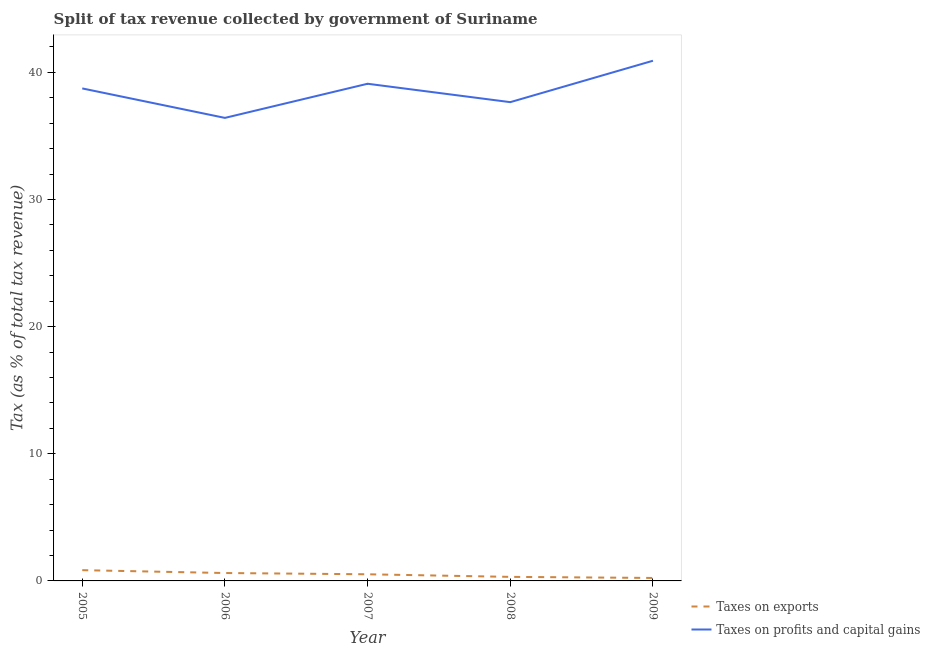How many different coloured lines are there?
Offer a very short reply. 2. Is the number of lines equal to the number of legend labels?
Your answer should be very brief. Yes. What is the percentage of revenue obtained from taxes on exports in 2005?
Your response must be concise. 0.85. Across all years, what is the maximum percentage of revenue obtained from taxes on profits and capital gains?
Provide a short and direct response. 40.91. Across all years, what is the minimum percentage of revenue obtained from taxes on exports?
Your answer should be very brief. 0.23. In which year was the percentage of revenue obtained from taxes on exports maximum?
Offer a terse response. 2005. What is the total percentage of revenue obtained from taxes on profits and capital gains in the graph?
Provide a short and direct response. 192.81. What is the difference between the percentage of revenue obtained from taxes on profits and capital gains in 2007 and that in 2009?
Make the answer very short. -1.81. What is the difference between the percentage of revenue obtained from taxes on exports in 2007 and the percentage of revenue obtained from taxes on profits and capital gains in 2005?
Offer a very short reply. -38.21. What is the average percentage of revenue obtained from taxes on profits and capital gains per year?
Ensure brevity in your answer.  38.56. In the year 2008, what is the difference between the percentage of revenue obtained from taxes on profits and capital gains and percentage of revenue obtained from taxes on exports?
Your answer should be very brief. 37.33. What is the ratio of the percentage of revenue obtained from taxes on exports in 2005 to that in 2007?
Provide a short and direct response. 1.62. What is the difference between the highest and the second highest percentage of revenue obtained from taxes on profits and capital gains?
Give a very brief answer. 1.81. What is the difference between the highest and the lowest percentage of revenue obtained from taxes on exports?
Make the answer very short. 0.61. In how many years, is the percentage of revenue obtained from taxes on profits and capital gains greater than the average percentage of revenue obtained from taxes on profits and capital gains taken over all years?
Give a very brief answer. 3. Is the sum of the percentage of revenue obtained from taxes on profits and capital gains in 2006 and 2008 greater than the maximum percentage of revenue obtained from taxes on exports across all years?
Ensure brevity in your answer.  Yes. Does the percentage of revenue obtained from taxes on exports monotonically increase over the years?
Ensure brevity in your answer.  No. Is the percentage of revenue obtained from taxes on profits and capital gains strictly less than the percentage of revenue obtained from taxes on exports over the years?
Ensure brevity in your answer.  No. How many years are there in the graph?
Keep it short and to the point. 5. Are the values on the major ticks of Y-axis written in scientific E-notation?
Your response must be concise. No. Does the graph contain grids?
Provide a succinct answer. No. How many legend labels are there?
Offer a terse response. 2. How are the legend labels stacked?
Your answer should be compact. Vertical. What is the title of the graph?
Your response must be concise. Split of tax revenue collected by government of Suriname. What is the label or title of the X-axis?
Your answer should be compact. Year. What is the label or title of the Y-axis?
Your answer should be compact. Tax (as % of total tax revenue). What is the Tax (as % of total tax revenue) of Taxes on exports in 2005?
Your answer should be very brief. 0.85. What is the Tax (as % of total tax revenue) in Taxes on profits and capital gains in 2005?
Provide a succinct answer. 38.73. What is the Tax (as % of total tax revenue) in Taxes on exports in 2006?
Make the answer very short. 0.62. What is the Tax (as % of total tax revenue) of Taxes on profits and capital gains in 2006?
Your answer should be compact. 36.42. What is the Tax (as % of total tax revenue) of Taxes on exports in 2007?
Your answer should be compact. 0.52. What is the Tax (as % of total tax revenue) in Taxes on profits and capital gains in 2007?
Offer a very short reply. 39.1. What is the Tax (as % of total tax revenue) of Taxes on exports in 2008?
Give a very brief answer. 0.32. What is the Tax (as % of total tax revenue) of Taxes on profits and capital gains in 2008?
Your answer should be very brief. 37.65. What is the Tax (as % of total tax revenue) in Taxes on exports in 2009?
Keep it short and to the point. 0.23. What is the Tax (as % of total tax revenue) of Taxes on profits and capital gains in 2009?
Your response must be concise. 40.91. Across all years, what is the maximum Tax (as % of total tax revenue) in Taxes on exports?
Provide a succinct answer. 0.85. Across all years, what is the maximum Tax (as % of total tax revenue) of Taxes on profits and capital gains?
Ensure brevity in your answer.  40.91. Across all years, what is the minimum Tax (as % of total tax revenue) in Taxes on exports?
Your answer should be compact. 0.23. Across all years, what is the minimum Tax (as % of total tax revenue) in Taxes on profits and capital gains?
Ensure brevity in your answer.  36.42. What is the total Tax (as % of total tax revenue) of Taxes on exports in the graph?
Offer a very short reply. 2.54. What is the total Tax (as % of total tax revenue) of Taxes on profits and capital gains in the graph?
Keep it short and to the point. 192.81. What is the difference between the Tax (as % of total tax revenue) in Taxes on exports in 2005 and that in 2006?
Provide a succinct answer. 0.23. What is the difference between the Tax (as % of total tax revenue) in Taxes on profits and capital gains in 2005 and that in 2006?
Make the answer very short. 2.32. What is the difference between the Tax (as % of total tax revenue) in Taxes on exports in 2005 and that in 2007?
Your response must be concise. 0.32. What is the difference between the Tax (as % of total tax revenue) in Taxes on profits and capital gains in 2005 and that in 2007?
Your answer should be very brief. -0.37. What is the difference between the Tax (as % of total tax revenue) of Taxes on exports in 2005 and that in 2008?
Your response must be concise. 0.53. What is the difference between the Tax (as % of total tax revenue) of Taxes on profits and capital gains in 2005 and that in 2008?
Keep it short and to the point. 1.08. What is the difference between the Tax (as % of total tax revenue) of Taxes on exports in 2005 and that in 2009?
Provide a succinct answer. 0.61. What is the difference between the Tax (as % of total tax revenue) in Taxes on profits and capital gains in 2005 and that in 2009?
Offer a very short reply. -2.18. What is the difference between the Tax (as % of total tax revenue) of Taxes on exports in 2006 and that in 2007?
Your answer should be very brief. 0.1. What is the difference between the Tax (as % of total tax revenue) of Taxes on profits and capital gains in 2006 and that in 2007?
Provide a succinct answer. -2.68. What is the difference between the Tax (as % of total tax revenue) of Taxes on exports in 2006 and that in 2008?
Provide a short and direct response. 0.3. What is the difference between the Tax (as % of total tax revenue) in Taxes on profits and capital gains in 2006 and that in 2008?
Your answer should be very brief. -1.24. What is the difference between the Tax (as % of total tax revenue) of Taxes on exports in 2006 and that in 2009?
Offer a terse response. 0.39. What is the difference between the Tax (as % of total tax revenue) in Taxes on profits and capital gains in 2006 and that in 2009?
Your answer should be very brief. -4.49. What is the difference between the Tax (as % of total tax revenue) in Taxes on exports in 2007 and that in 2008?
Offer a very short reply. 0.2. What is the difference between the Tax (as % of total tax revenue) of Taxes on profits and capital gains in 2007 and that in 2008?
Make the answer very short. 1.45. What is the difference between the Tax (as % of total tax revenue) of Taxes on exports in 2007 and that in 2009?
Your answer should be compact. 0.29. What is the difference between the Tax (as % of total tax revenue) of Taxes on profits and capital gains in 2007 and that in 2009?
Offer a terse response. -1.81. What is the difference between the Tax (as % of total tax revenue) of Taxes on exports in 2008 and that in 2009?
Offer a terse response. 0.09. What is the difference between the Tax (as % of total tax revenue) of Taxes on profits and capital gains in 2008 and that in 2009?
Make the answer very short. -3.26. What is the difference between the Tax (as % of total tax revenue) in Taxes on exports in 2005 and the Tax (as % of total tax revenue) in Taxes on profits and capital gains in 2006?
Keep it short and to the point. -35.57. What is the difference between the Tax (as % of total tax revenue) in Taxes on exports in 2005 and the Tax (as % of total tax revenue) in Taxes on profits and capital gains in 2007?
Offer a terse response. -38.25. What is the difference between the Tax (as % of total tax revenue) in Taxes on exports in 2005 and the Tax (as % of total tax revenue) in Taxes on profits and capital gains in 2008?
Your answer should be very brief. -36.81. What is the difference between the Tax (as % of total tax revenue) in Taxes on exports in 2005 and the Tax (as % of total tax revenue) in Taxes on profits and capital gains in 2009?
Keep it short and to the point. -40.06. What is the difference between the Tax (as % of total tax revenue) of Taxes on exports in 2006 and the Tax (as % of total tax revenue) of Taxes on profits and capital gains in 2007?
Offer a very short reply. -38.48. What is the difference between the Tax (as % of total tax revenue) in Taxes on exports in 2006 and the Tax (as % of total tax revenue) in Taxes on profits and capital gains in 2008?
Your answer should be compact. -37.03. What is the difference between the Tax (as % of total tax revenue) in Taxes on exports in 2006 and the Tax (as % of total tax revenue) in Taxes on profits and capital gains in 2009?
Your response must be concise. -40.29. What is the difference between the Tax (as % of total tax revenue) of Taxes on exports in 2007 and the Tax (as % of total tax revenue) of Taxes on profits and capital gains in 2008?
Your answer should be very brief. -37.13. What is the difference between the Tax (as % of total tax revenue) of Taxes on exports in 2007 and the Tax (as % of total tax revenue) of Taxes on profits and capital gains in 2009?
Keep it short and to the point. -40.39. What is the difference between the Tax (as % of total tax revenue) of Taxes on exports in 2008 and the Tax (as % of total tax revenue) of Taxes on profits and capital gains in 2009?
Give a very brief answer. -40.59. What is the average Tax (as % of total tax revenue) in Taxes on exports per year?
Provide a short and direct response. 0.51. What is the average Tax (as % of total tax revenue) of Taxes on profits and capital gains per year?
Your answer should be compact. 38.56. In the year 2005, what is the difference between the Tax (as % of total tax revenue) in Taxes on exports and Tax (as % of total tax revenue) in Taxes on profits and capital gains?
Give a very brief answer. -37.89. In the year 2006, what is the difference between the Tax (as % of total tax revenue) in Taxes on exports and Tax (as % of total tax revenue) in Taxes on profits and capital gains?
Offer a very short reply. -35.79. In the year 2007, what is the difference between the Tax (as % of total tax revenue) in Taxes on exports and Tax (as % of total tax revenue) in Taxes on profits and capital gains?
Ensure brevity in your answer.  -38.58. In the year 2008, what is the difference between the Tax (as % of total tax revenue) of Taxes on exports and Tax (as % of total tax revenue) of Taxes on profits and capital gains?
Your answer should be compact. -37.34. In the year 2009, what is the difference between the Tax (as % of total tax revenue) of Taxes on exports and Tax (as % of total tax revenue) of Taxes on profits and capital gains?
Provide a short and direct response. -40.68. What is the ratio of the Tax (as % of total tax revenue) in Taxes on exports in 2005 to that in 2006?
Your response must be concise. 1.36. What is the ratio of the Tax (as % of total tax revenue) in Taxes on profits and capital gains in 2005 to that in 2006?
Keep it short and to the point. 1.06. What is the ratio of the Tax (as % of total tax revenue) in Taxes on exports in 2005 to that in 2007?
Your answer should be compact. 1.62. What is the ratio of the Tax (as % of total tax revenue) of Taxes on profits and capital gains in 2005 to that in 2007?
Provide a succinct answer. 0.99. What is the ratio of the Tax (as % of total tax revenue) in Taxes on exports in 2005 to that in 2008?
Provide a short and direct response. 2.66. What is the ratio of the Tax (as % of total tax revenue) in Taxes on profits and capital gains in 2005 to that in 2008?
Give a very brief answer. 1.03. What is the ratio of the Tax (as % of total tax revenue) of Taxes on exports in 2005 to that in 2009?
Keep it short and to the point. 3.63. What is the ratio of the Tax (as % of total tax revenue) in Taxes on profits and capital gains in 2005 to that in 2009?
Keep it short and to the point. 0.95. What is the ratio of the Tax (as % of total tax revenue) of Taxes on exports in 2006 to that in 2007?
Your answer should be very brief. 1.19. What is the ratio of the Tax (as % of total tax revenue) of Taxes on profits and capital gains in 2006 to that in 2007?
Provide a short and direct response. 0.93. What is the ratio of the Tax (as % of total tax revenue) in Taxes on exports in 2006 to that in 2008?
Offer a terse response. 1.95. What is the ratio of the Tax (as % of total tax revenue) of Taxes on profits and capital gains in 2006 to that in 2008?
Keep it short and to the point. 0.97. What is the ratio of the Tax (as % of total tax revenue) of Taxes on exports in 2006 to that in 2009?
Provide a short and direct response. 2.66. What is the ratio of the Tax (as % of total tax revenue) in Taxes on profits and capital gains in 2006 to that in 2009?
Ensure brevity in your answer.  0.89. What is the ratio of the Tax (as % of total tax revenue) of Taxes on exports in 2007 to that in 2008?
Give a very brief answer. 1.64. What is the ratio of the Tax (as % of total tax revenue) in Taxes on profits and capital gains in 2007 to that in 2008?
Your answer should be very brief. 1.04. What is the ratio of the Tax (as % of total tax revenue) of Taxes on exports in 2007 to that in 2009?
Offer a terse response. 2.24. What is the ratio of the Tax (as % of total tax revenue) of Taxes on profits and capital gains in 2007 to that in 2009?
Give a very brief answer. 0.96. What is the ratio of the Tax (as % of total tax revenue) in Taxes on exports in 2008 to that in 2009?
Keep it short and to the point. 1.37. What is the ratio of the Tax (as % of total tax revenue) in Taxes on profits and capital gains in 2008 to that in 2009?
Ensure brevity in your answer.  0.92. What is the difference between the highest and the second highest Tax (as % of total tax revenue) of Taxes on exports?
Provide a short and direct response. 0.23. What is the difference between the highest and the second highest Tax (as % of total tax revenue) of Taxes on profits and capital gains?
Your response must be concise. 1.81. What is the difference between the highest and the lowest Tax (as % of total tax revenue) in Taxes on exports?
Provide a succinct answer. 0.61. What is the difference between the highest and the lowest Tax (as % of total tax revenue) in Taxes on profits and capital gains?
Your response must be concise. 4.49. 